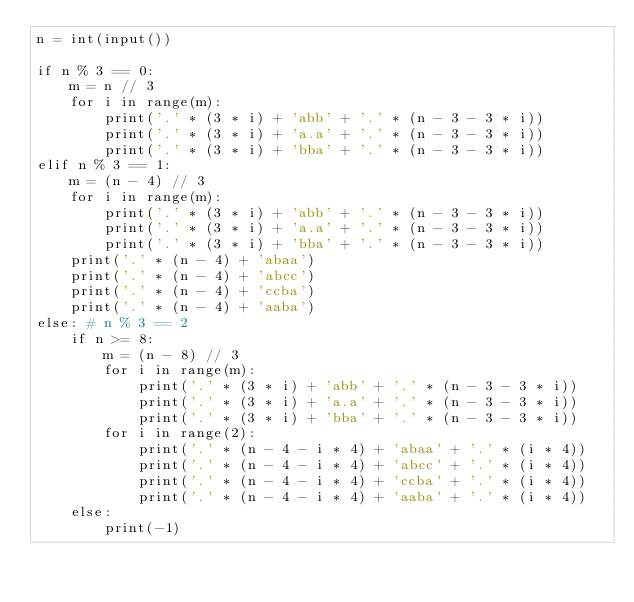<code> <loc_0><loc_0><loc_500><loc_500><_Python_>n = int(input())

if n % 3 == 0:
    m = n // 3
    for i in range(m):
        print('.' * (3 * i) + 'abb' + '.' * (n - 3 - 3 * i))
        print('.' * (3 * i) + 'a.a' + '.' * (n - 3 - 3 * i))
        print('.' * (3 * i) + 'bba' + '.' * (n - 3 - 3 * i))
elif n % 3 == 1:
    m = (n - 4) // 3
    for i in range(m):
        print('.' * (3 * i) + 'abb' + '.' * (n - 3 - 3 * i))
        print('.' * (3 * i) + 'a.a' + '.' * (n - 3 - 3 * i))
        print('.' * (3 * i) + 'bba' + '.' * (n - 3 - 3 * i))
    print('.' * (n - 4) + 'abaa')
    print('.' * (n - 4) + 'abcc')
    print('.' * (n - 4) + 'ccba')
    print('.' * (n - 4) + 'aaba')
else: # n % 3 == 2
    if n >= 8:
        m = (n - 8) // 3
        for i in range(m):
            print('.' * (3 * i) + 'abb' + '.' * (n - 3 - 3 * i))
            print('.' * (3 * i) + 'a.a' + '.' * (n - 3 - 3 * i))
            print('.' * (3 * i) + 'bba' + '.' * (n - 3 - 3 * i))
        for i in range(2):
            print('.' * (n - 4 - i * 4) + 'abaa' + '.' * (i * 4))
            print('.' * (n - 4 - i * 4) + 'abcc' + '.' * (i * 4))
            print('.' * (n - 4 - i * 4) + 'ccba' + '.' * (i * 4))
            print('.' * (n - 4 - i * 4) + 'aaba' + '.' * (i * 4))
    else:
        print(-1)
</code> 